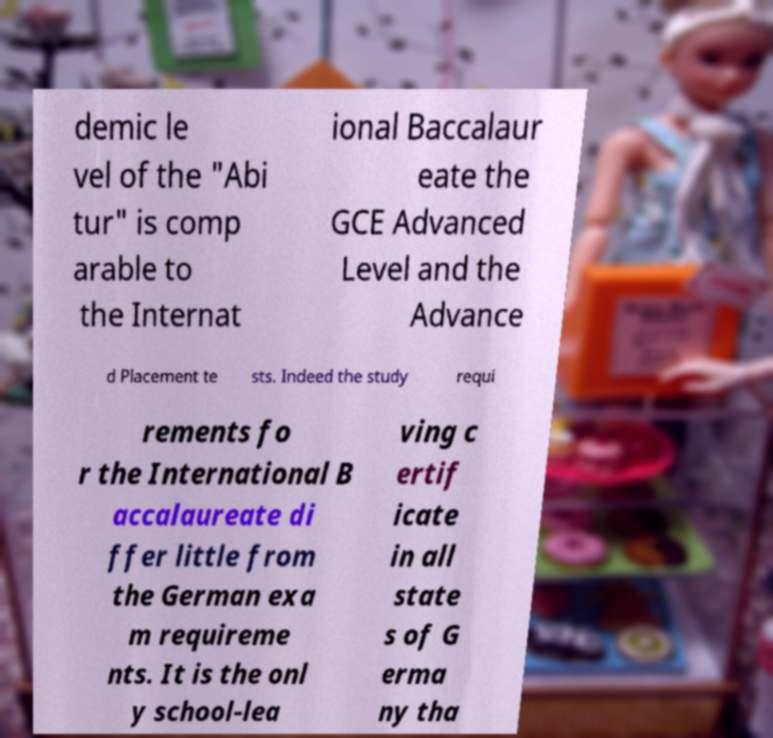Could you assist in decoding the text presented in this image and type it out clearly? demic le vel of the "Abi tur" is comp arable to the Internat ional Baccalaur eate the GCE Advanced Level and the Advance d Placement te sts. Indeed the study requi rements fo r the International B accalaureate di ffer little from the German exa m requireme nts. It is the onl y school-lea ving c ertif icate in all state s of G erma ny tha 